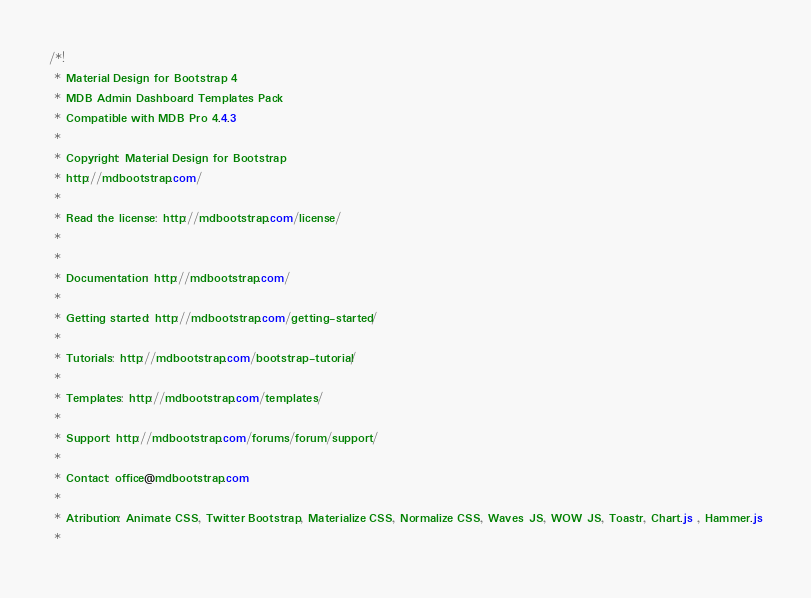<code> <loc_0><loc_0><loc_500><loc_500><_CSS_>/*!
 * Material Design for Bootstrap 4
 * MDB Admin Dashboard Templates Pack
 * Compatible with MDB Pro 4.4.3
 *
 * Copyright: Material Design for Bootstrap
 * http://mdbootstrap.com/
 *
 * Read the license: http://mdbootstrap.com/license/
 *
 *
 * Documentation: http://mdbootstrap.com/
 *
 * Getting started: http://mdbootstrap.com/getting-started/
 *
 * Tutorials: http://mdbootstrap.com/bootstrap-tutorial/
 *
 * Templates: http://mdbootstrap.com/templates/
 *
 * Support: http://mdbootstrap.com/forums/forum/support/
 *
 * Contact: office@mdbootstrap.com 
 *
 * Atribution: Animate CSS, Twitter Bootstrap, Materialize CSS, Normalize CSS, Waves JS, WOW JS, Toastr, Chart.js , Hammer.js
 *</code> 